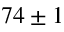<formula> <loc_0><loc_0><loc_500><loc_500>7 4 \pm 1</formula> 